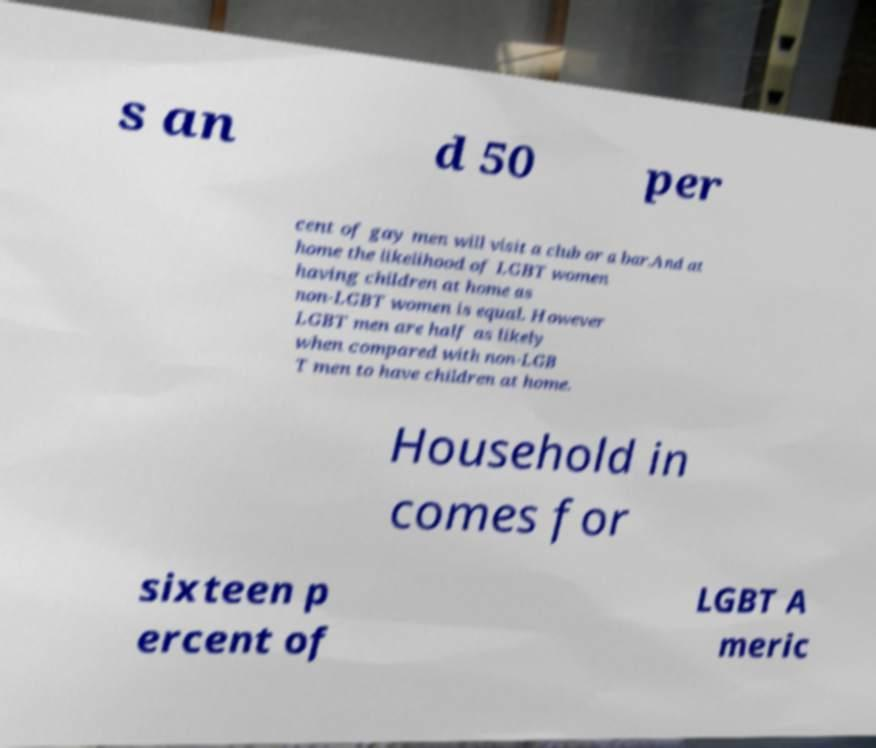For documentation purposes, I need the text within this image transcribed. Could you provide that? s an d 50 per cent of gay men will visit a club or a bar.And at home the likelihood of LGBT women having children at home as non-LGBT women is equal. However LGBT men are half as likely when compared with non-LGB T men to have children at home. Household in comes for sixteen p ercent of LGBT A meric 